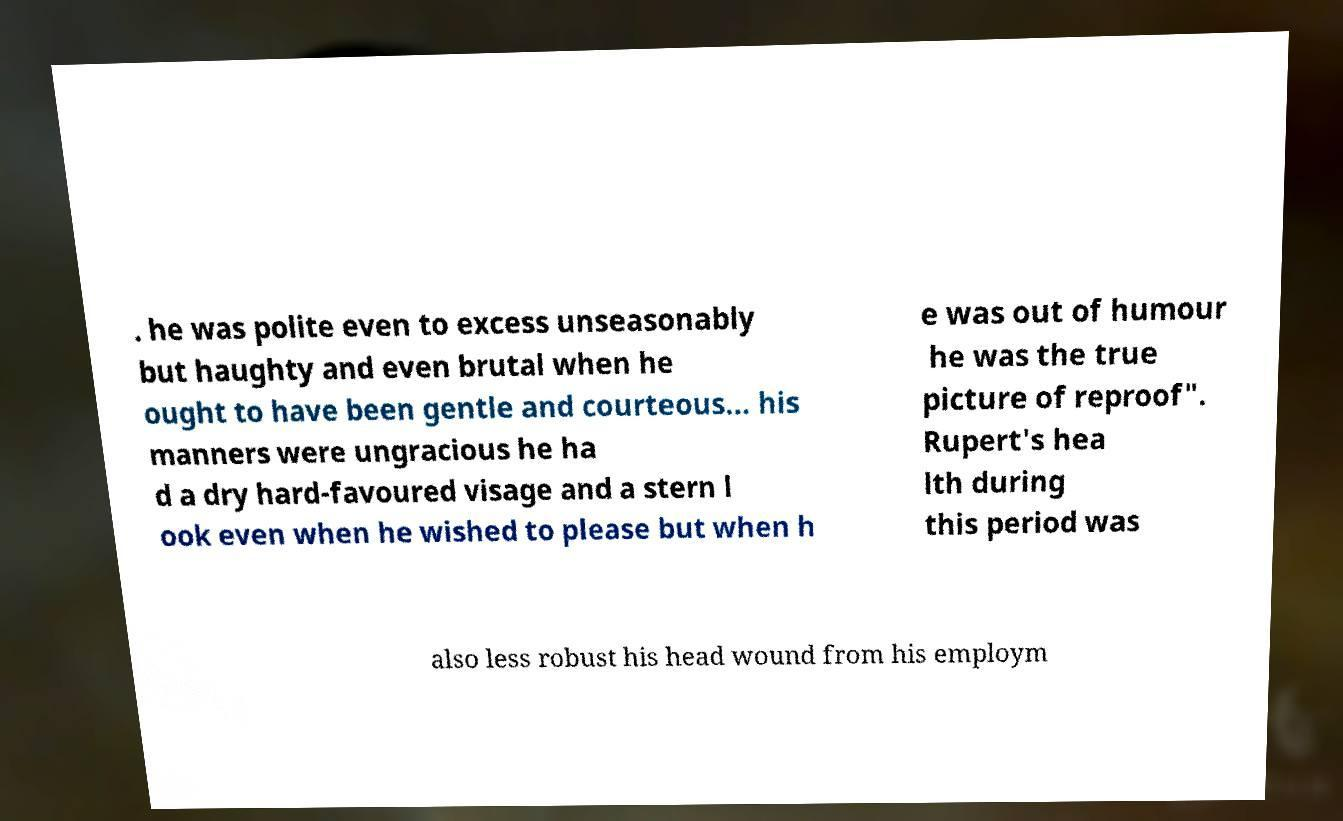For documentation purposes, I need the text within this image transcribed. Could you provide that? . he was polite even to excess unseasonably but haughty and even brutal when he ought to have been gentle and courteous... his manners were ungracious he ha d a dry hard-favoured visage and a stern l ook even when he wished to please but when h e was out of humour he was the true picture of reproof". Rupert's hea lth during this period was also less robust his head wound from his employm 